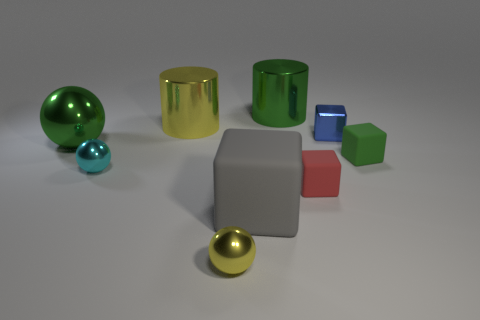Does the red thing have the same shape as the yellow shiny object in front of the small cyan sphere?
Your answer should be very brief. No. There is a green thing that is both left of the tiny green matte object and in front of the big yellow cylinder; how big is it?
Ensure brevity in your answer.  Large. What color is the tiny metallic object that is on the right side of the small cyan ball and left of the red rubber cube?
Ensure brevity in your answer.  Yellow. Is there any other thing that is the same material as the yellow cylinder?
Ensure brevity in your answer.  Yes. Are there fewer green blocks behind the green metallic sphere than small blue metal blocks on the left side of the red rubber block?
Ensure brevity in your answer.  No. Is there anything else that has the same color as the large metallic ball?
Provide a short and direct response. Yes. What shape is the tiny green thing?
Your response must be concise. Cube. What is the color of the small block that is the same material as the green cylinder?
Provide a succinct answer. Blue. Is the number of gray objects greater than the number of tiny blue rubber spheres?
Offer a very short reply. Yes. Are there any blue shiny objects?
Provide a short and direct response. Yes. 